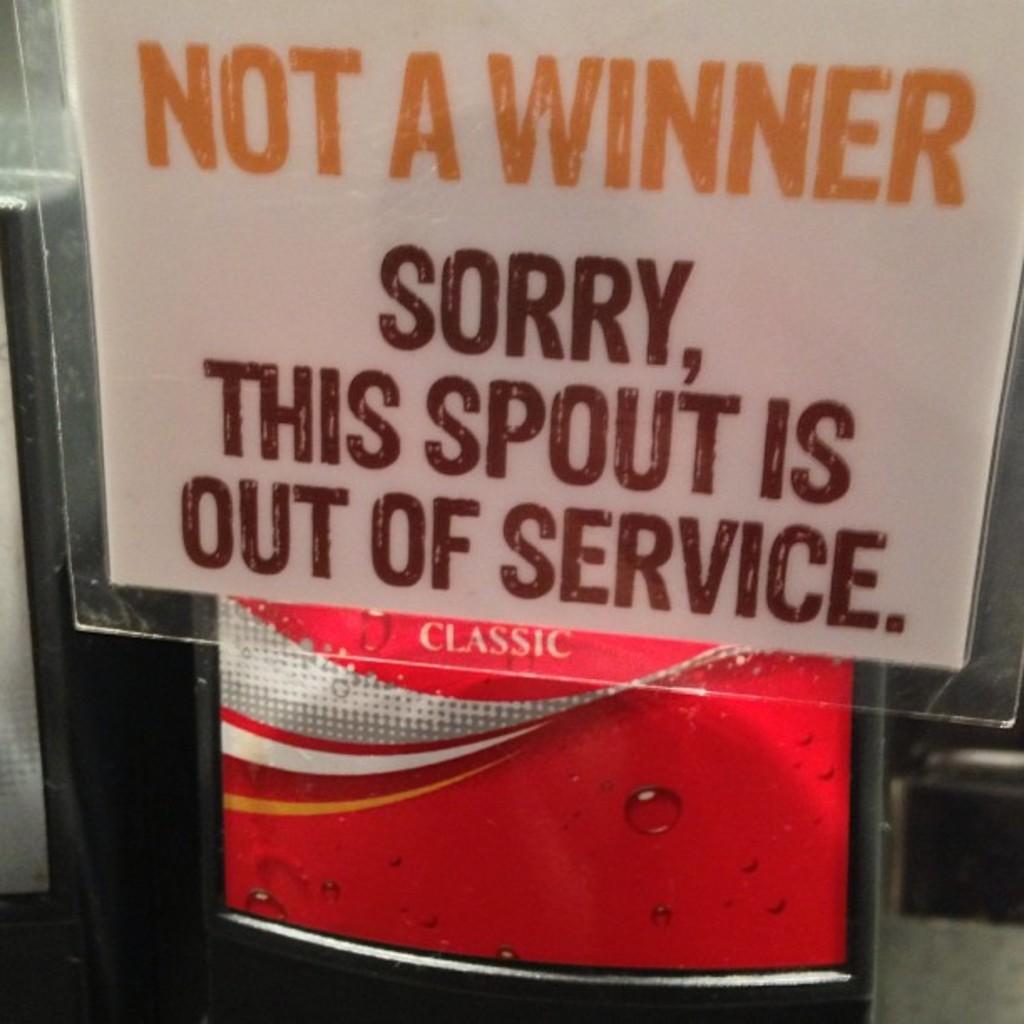How would you summarize this image in a sentence or two? In this image we can see there is a board which made by the glass, on it some text written. 